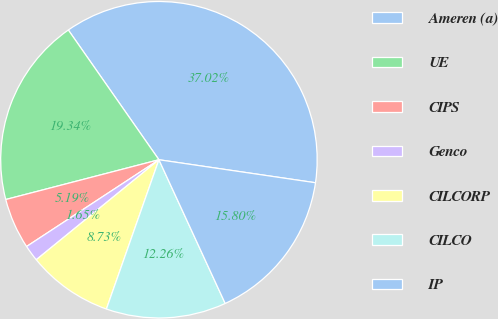Convert chart. <chart><loc_0><loc_0><loc_500><loc_500><pie_chart><fcel>Ameren (a)<fcel>UE<fcel>CIPS<fcel>Genco<fcel>CILCORP<fcel>CILCO<fcel>IP<nl><fcel>37.02%<fcel>19.34%<fcel>5.19%<fcel>1.65%<fcel>8.73%<fcel>12.26%<fcel>15.8%<nl></chart> 